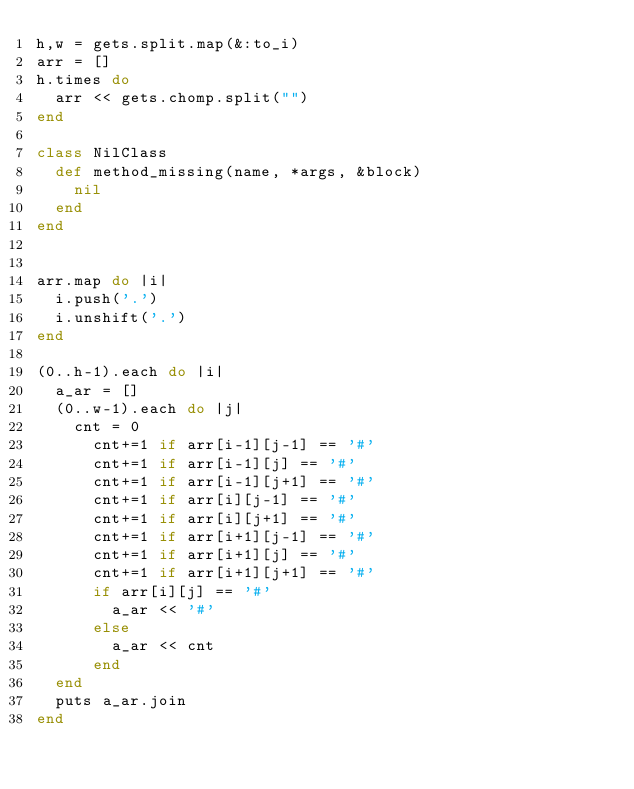Convert code to text. <code><loc_0><loc_0><loc_500><loc_500><_Ruby_>h,w = gets.split.map(&:to_i)
arr = []
h.times do
  arr << gets.chomp.split("")
end

class NilClass
  def method_missing(name, *args, &block)
    nil
  end
end


arr.map do |i|
  i.push('.')
  i.unshift('.')
end

(0..h-1).each do |i|
  a_ar = []
  (0..w-1).each do |j|
    cnt = 0
      cnt+=1 if arr[i-1][j-1] == '#'
      cnt+=1 if arr[i-1][j] == '#'
      cnt+=1 if arr[i-1][j+1] == '#'
      cnt+=1 if arr[i][j-1] == '#'
      cnt+=1 if arr[i][j+1] == '#'
      cnt+=1 if arr[i+1][j-1] == '#'
      cnt+=1 if arr[i+1][j] == '#'
      cnt+=1 if arr[i+1][j+1] == '#'
      if arr[i][j] == '#'
        a_ar << '#'
      else
        a_ar << cnt
      end
  end
  puts a_ar.join
end
</code> 